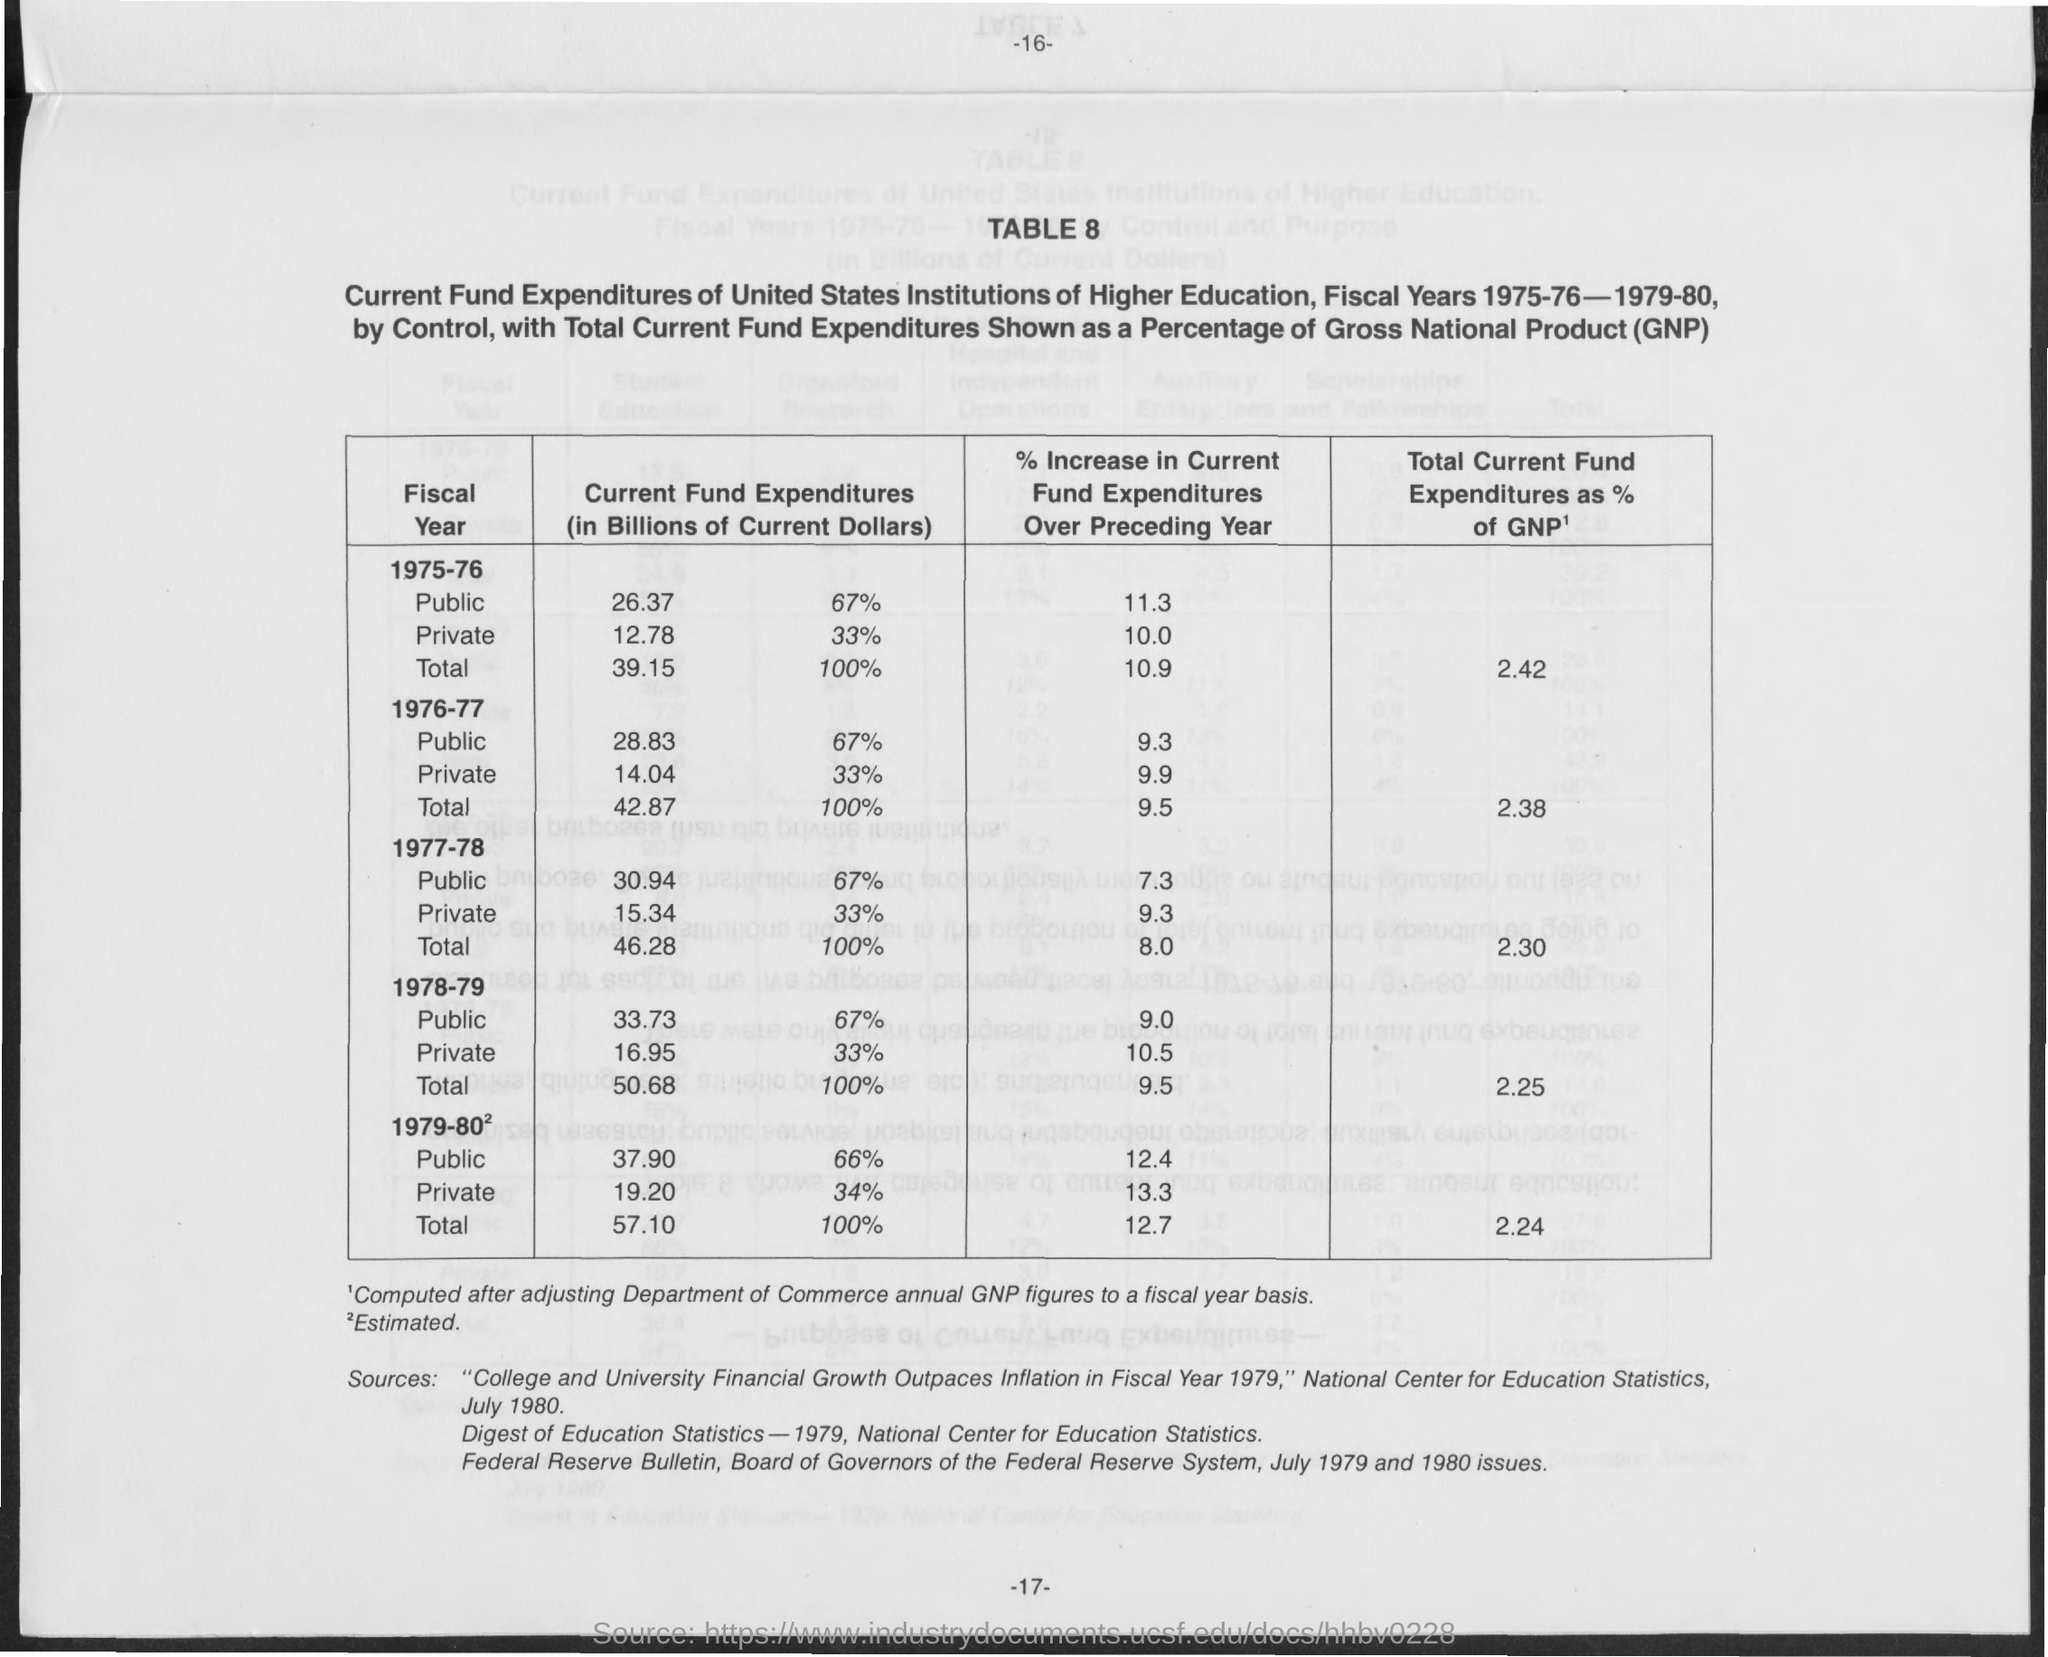Indicate a few pertinent items in this graphic. The total current fund expenditures as a percentage of GNP for the year 1975-76 was 2.42%. GNP stands for Gross National Product, a measure of the total value of goods and services produced by a country's citizens and businesses, as well as the income received from foreign sources, minus any income paid to foreigners for the same services. Total current fund expenditures as a percentage of GNP for the year 1979-80 was 2.24%. The total current fund expenditures as a percentage of GNP for the year 1977-78 was 2.30%. The total current fund expenditures as a percentage of GNP for the year 1976-77 was 2.38%. 